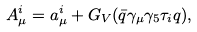<formula> <loc_0><loc_0><loc_500><loc_500>A _ { \mu } ^ { i } = a _ { \mu } ^ { i } + G _ { V } ( \bar { q } \gamma _ { \mu } \gamma _ { 5 } \tau _ { i } q ) ,</formula> 